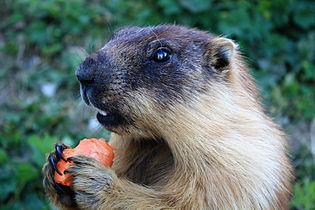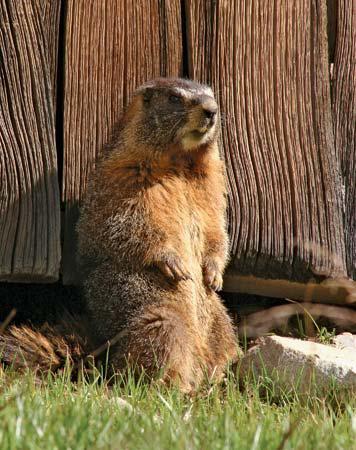The first image is the image on the left, the second image is the image on the right. For the images displayed, is the sentence "The right image contains a rodent standing on grass." factually correct? Answer yes or no. Yes. The first image is the image on the left, the second image is the image on the right. Given the left and right images, does the statement "the animal in the image on the left is facing right" hold true? Answer yes or no. No. The first image is the image on the left, the second image is the image on the right. Considering the images on both sides, is "Marmot in right image is standing up with arms dangling in front." valid? Answer yes or no. Yes. The first image is the image on the left, the second image is the image on the right. Assess this claim about the two images: "A marmot is standing with its front paws raised towards its mouth in a clasping pose.". Correct or not? Answer yes or no. Yes. 